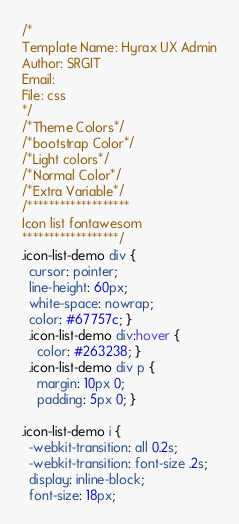Convert code to text. <code><loc_0><loc_0><loc_500><loc_500><_CSS_>/*
Template Name: Hyrax UX Admin
Author: SRGIT
Email: 
File: css
*/
/*Theme Colors*/
/*bootstrap Color*/
/*Light colors*/
/*Normal Color*/
/*Extra Variable*/
/*******************
Icon list fontawesom
******************/
.icon-list-demo div {
  cursor: pointer;
  line-height: 60px;
  white-space: nowrap;
  color: #67757c; }
  .icon-list-demo div:hover {
    color: #263238; }
  .icon-list-demo div p {
    margin: 10px 0;
    padding: 5px 0; }

.icon-list-demo i {
  -webkit-transition: all 0.2s;
  -webkit-transition: font-size .2s;
  display: inline-block;
  font-size: 18px;</code> 